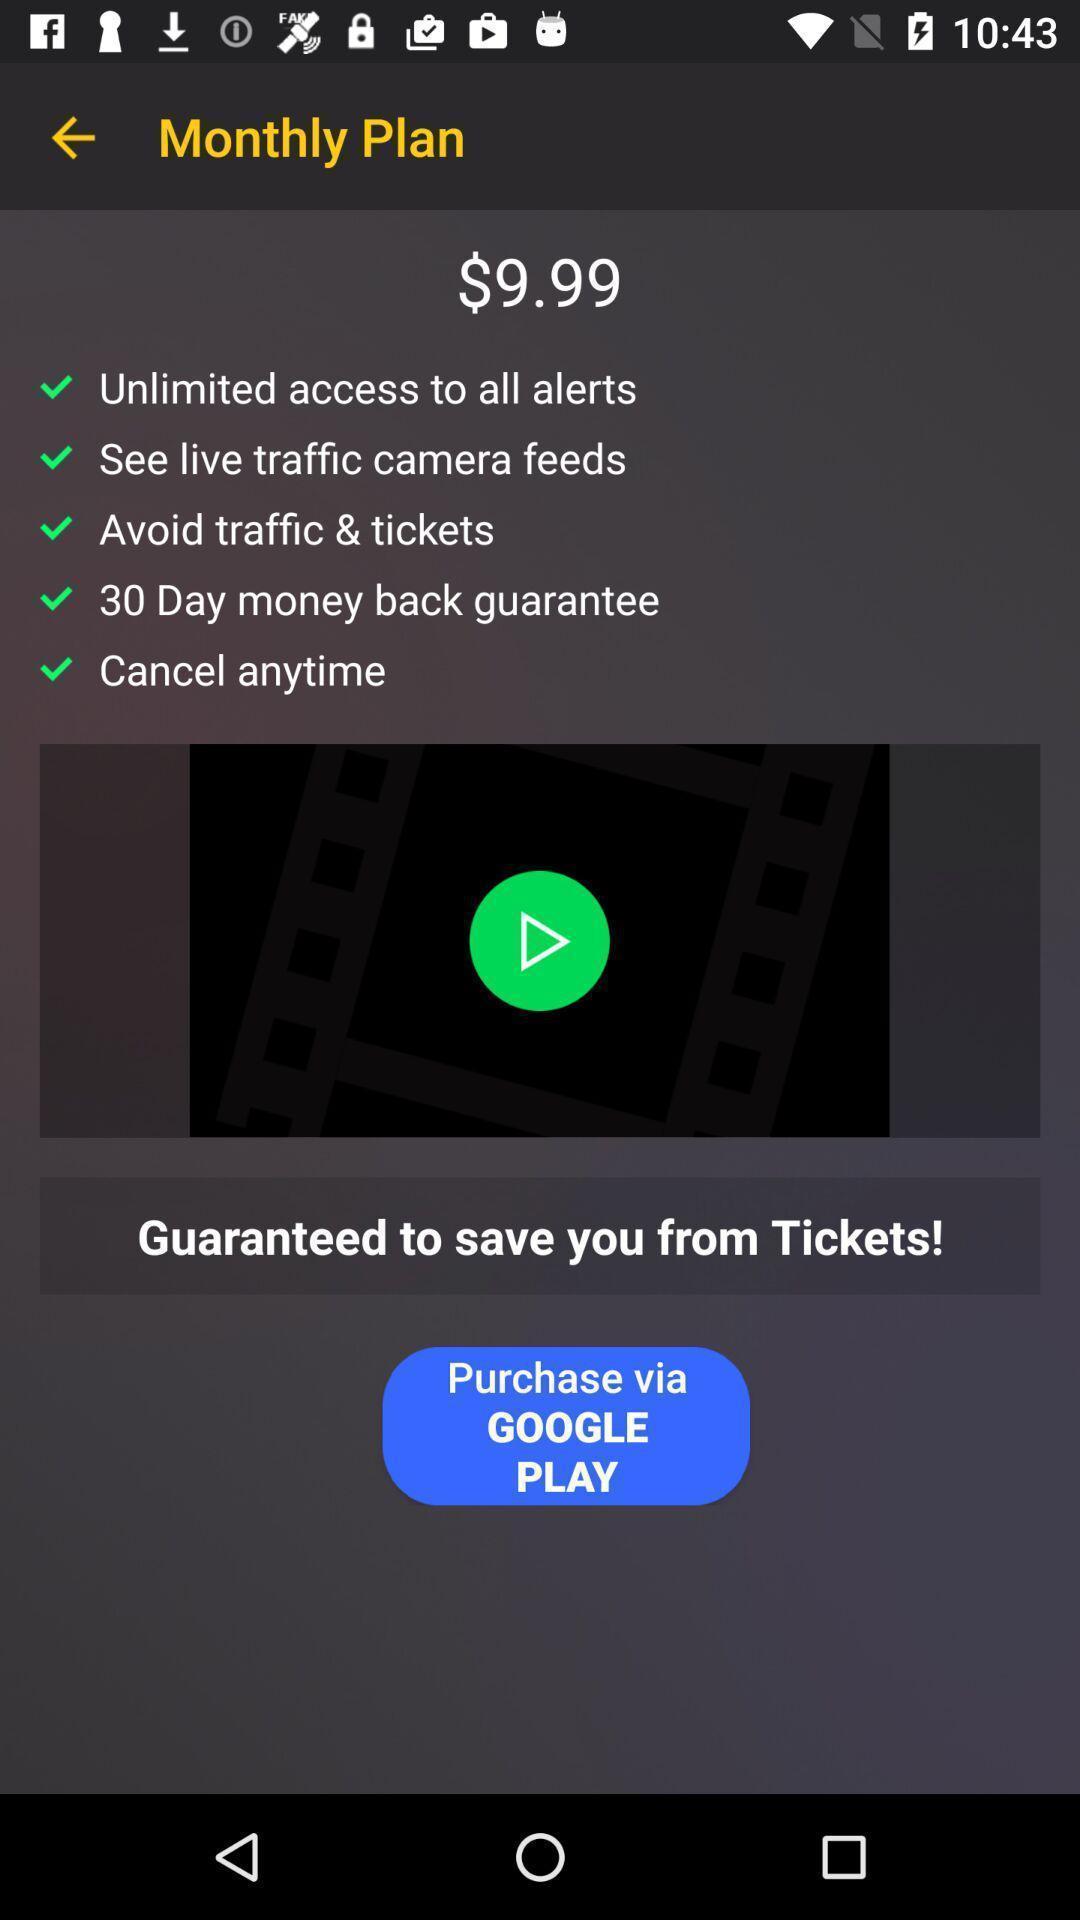Explain what's happening in this screen capture. Page showing the monthly plan details. 